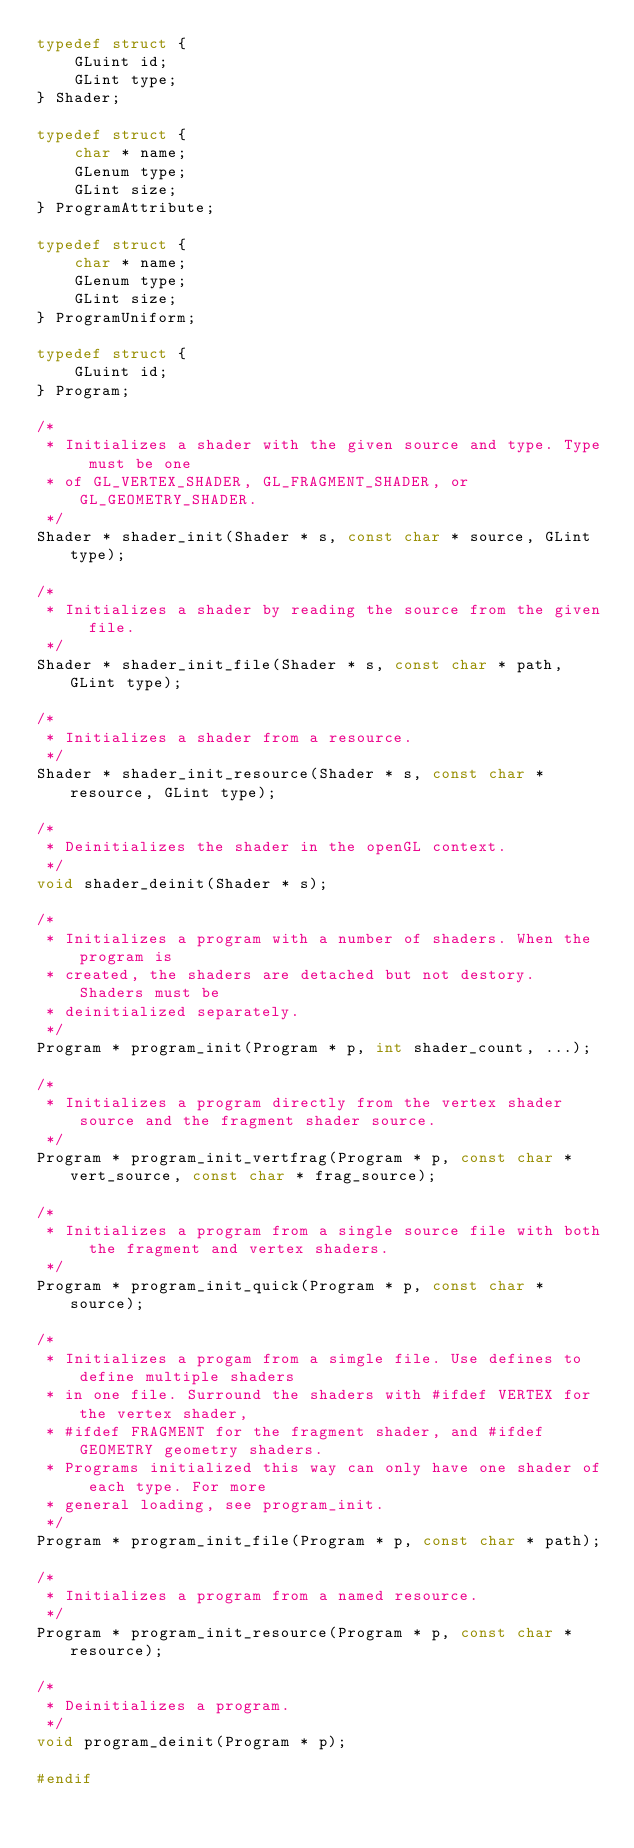<code> <loc_0><loc_0><loc_500><loc_500><_C_>typedef struct {
    GLuint id;
    GLint type;
} Shader;

typedef struct {
    char * name;
    GLenum type;
    GLint size;
} ProgramAttribute;

typedef struct {
    char * name;
    GLenum type;
    GLint size;
} ProgramUniform;

typedef struct {
    GLuint id;
} Program;

/*
 * Initializes a shader with the given source and type. Type must be one
 * of GL_VERTEX_SHADER, GL_FRAGMENT_SHADER, or GL_GEOMETRY_SHADER.
 */
Shader * shader_init(Shader * s, const char * source, GLint type);

/*
 * Initializes a shader by reading the source from the given file.
 */
Shader * shader_init_file(Shader * s, const char * path, GLint type);

/*
 * Initializes a shader from a resource.
 */
Shader * shader_init_resource(Shader * s, const char * resource, GLint type);

/*
 * Deinitializes the shader in the openGL context.
 */
void shader_deinit(Shader * s);

/*
 * Initializes a program with a number of shaders. When the program is
 * created, the shaders are detached but not destory. Shaders must be
 * deinitialized separately.
 */
Program * program_init(Program * p, int shader_count, ...);

/*
 * Initializes a program directly from the vertex shader source and the fragment shader source.
 */
Program * program_init_vertfrag(Program * p, const char * vert_source, const char * frag_source);

/*
 * Initializes a program from a single source file with both the fragment and vertex shaders.
 */
Program * program_init_quick(Program * p, const char * source);

/*
 * Initializes a progam from a simgle file. Use defines to define multiple shaders
 * in one file. Surround the shaders with #ifdef VERTEX for the vertex shader,
 * #ifdef FRAGMENT for the fragment shader, and #ifdef GEOMETRY geometry shaders.
 * Programs initialized this way can only have one shader of each type. For more
 * general loading, see program_init.
 */
Program * program_init_file(Program * p, const char * path);

/*
 * Initializes a program from a named resource.
 */
Program * program_init_resource(Program * p, const char * resource);

/*
 * Deinitializes a program.
 */
void program_deinit(Program * p);

#endif
</code> 